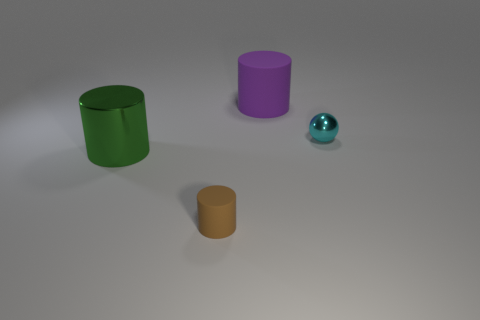Subtract all matte cylinders. How many cylinders are left? 1 Add 4 brown objects. How many objects exist? 8 Subtract all spheres. How many objects are left? 3 Subtract all cyan cylinders. Subtract all brown blocks. How many cylinders are left? 3 Subtract all big green things. Subtract all big objects. How many objects are left? 1 Add 1 small cyan metallic things. How many small cyan metallic things are left? 2 Add 1 metallic balls. How many metallic balls exist? 2 Subtract 0 brown cubes. How many objects are left? 4 